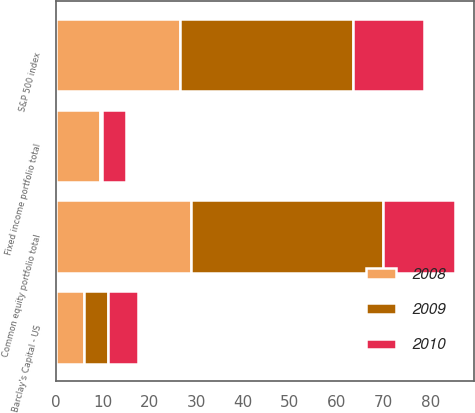Convert chart to OTSL. <chart><loc_0><loc_0><loc_500><loc_500><stacked_bar_chart><ecel><fcel>Fixed income portfolio total<fcel>Barclay's Capital - US<fcel>Common equity portfolio total<fcel>S&P 500 index<nl><fcel>2010<fcel>5.3<fcel>6.5<fcel>15.4<fcel>15.1<nl><fcel>2008<fcel>9.4<fcel>5.9<fcel>28.9<fcel>26.5<nl><fcel>2009<fcel>0.3<fcel>5.2<fcel>40.9<fcel>37<nl></chart> 